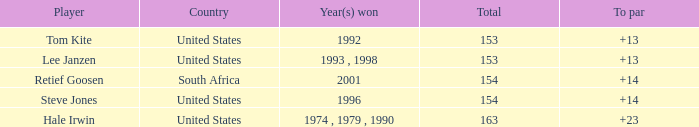Parse the full table. {'header': ['Player', 'Country', 'Year(s) won', 'Total', 'To par'], 'rows': [['Tom Kite', 'United States', '1992', '153', '+13'], ['Lee Janzen', 'United States', '1993 , 1998', '153', '+13'], ['Retief Goosen', 'South Africa', '2001', '154', '+14'], ['Steve Jones', 'United States', '1996', '154', '+14'], ['Hale Irwin', 'United States', '1974 , 1979 , 1990', '163', '+23']]} In what year did the United States win To par greater than 14 1974 , 1979 , 1990. 